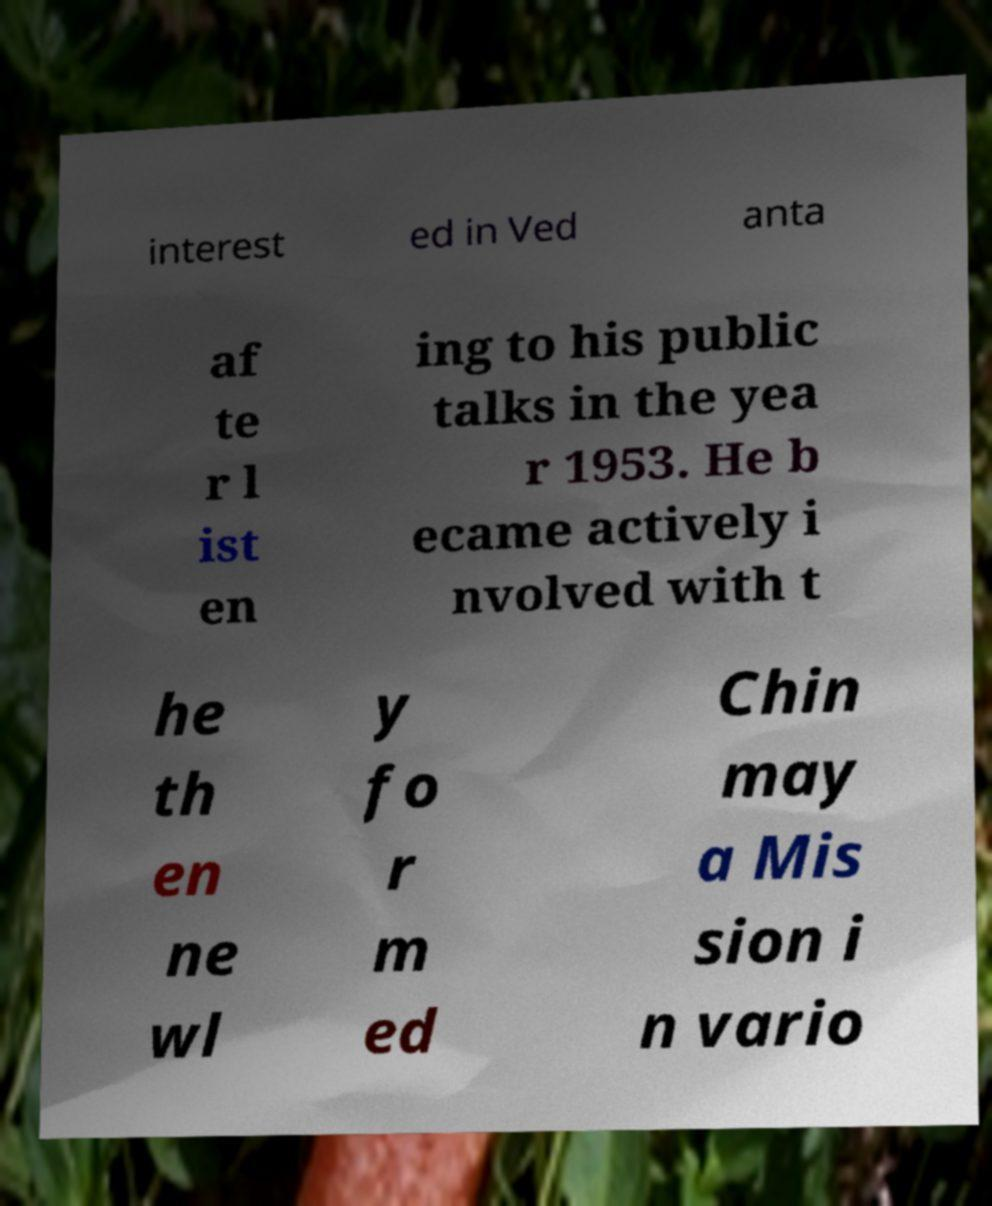I need the written content from this picture converted into text. Can you do that? interest ed in Ved anta af te r l ist en ing to his public talks in the yea r 1953. He b ecame actively i nvolved with t he th en ne wl y fo r m ed Chin may a Mis sion i n vario 